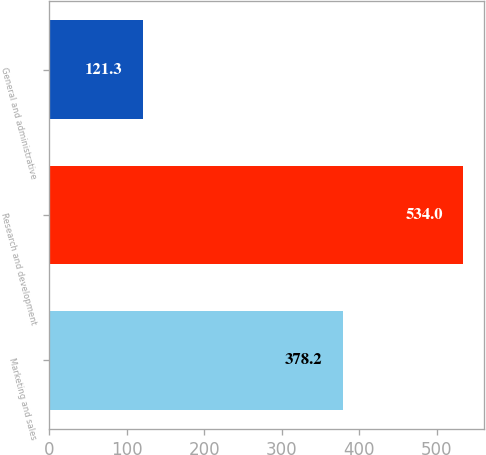Convert chart. <chart><loc_0><loc_0><loc_500><loc_500><bar_chart><fcel>Marketing and sales<fcel>Research and development<fcel>General and administrative<nl><fcel>378.2<fcel>534<fcel>121.3<nl></chart> 